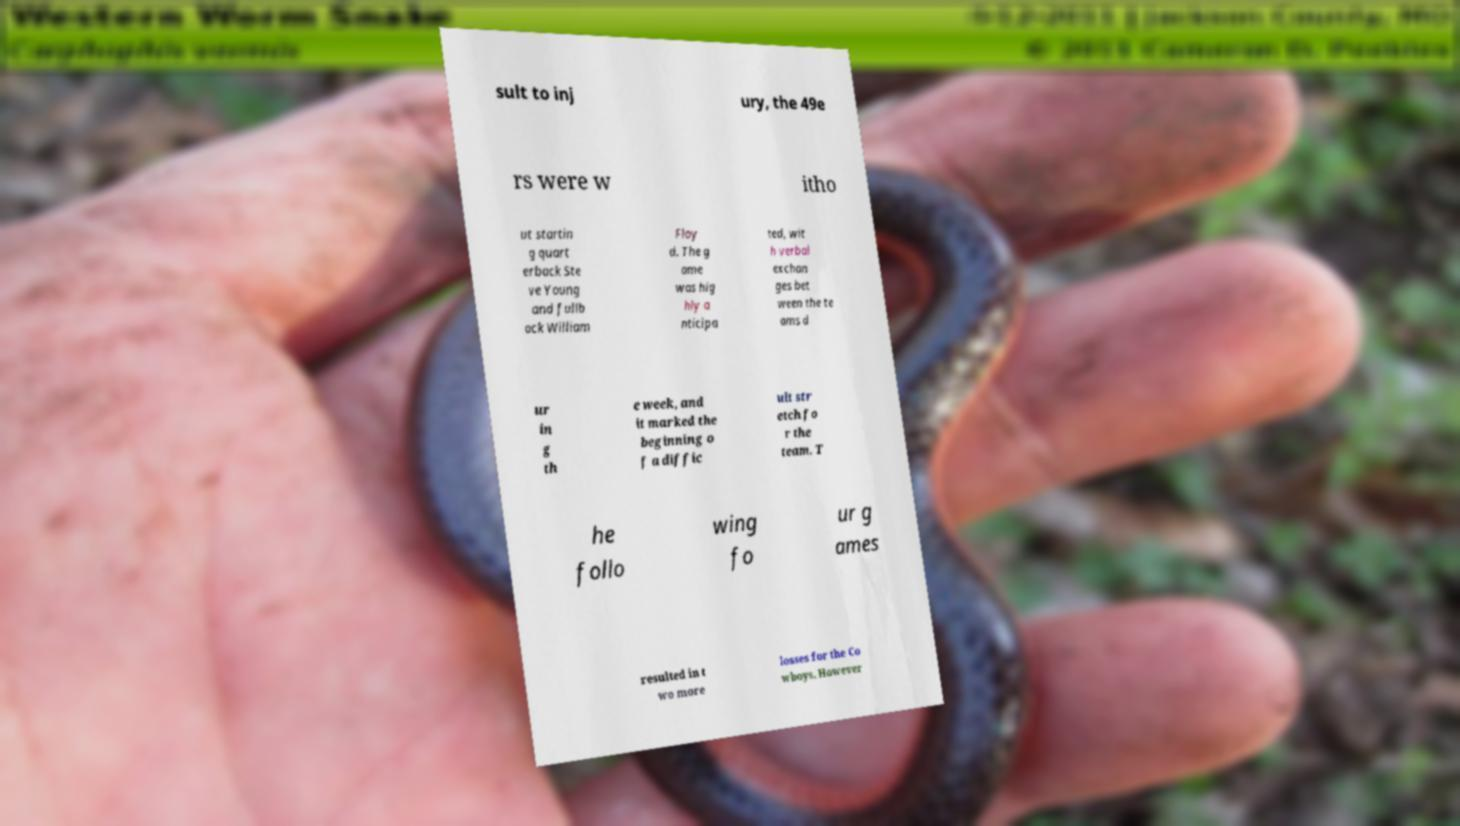There's text embedded in this image that I need extracted. Can you transcribe it verbatim? sult to inj ury, the 49e rs were w itho ut startin g quart erback Ste ve Young and fullb ack William Floy d. The g ame was hig hly a nticipa ted, wit h verbal exchan ges bet ween the te ams d ur in g th e week, and it marked the beginning o f a diffic ult str etch fo r the team. T he follo wing fo ur g ames resulted in t wo more losses for the Co wboys. However 